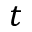<formula> <loc_0><loc_0><loc_500><loc_500>t</formula> 